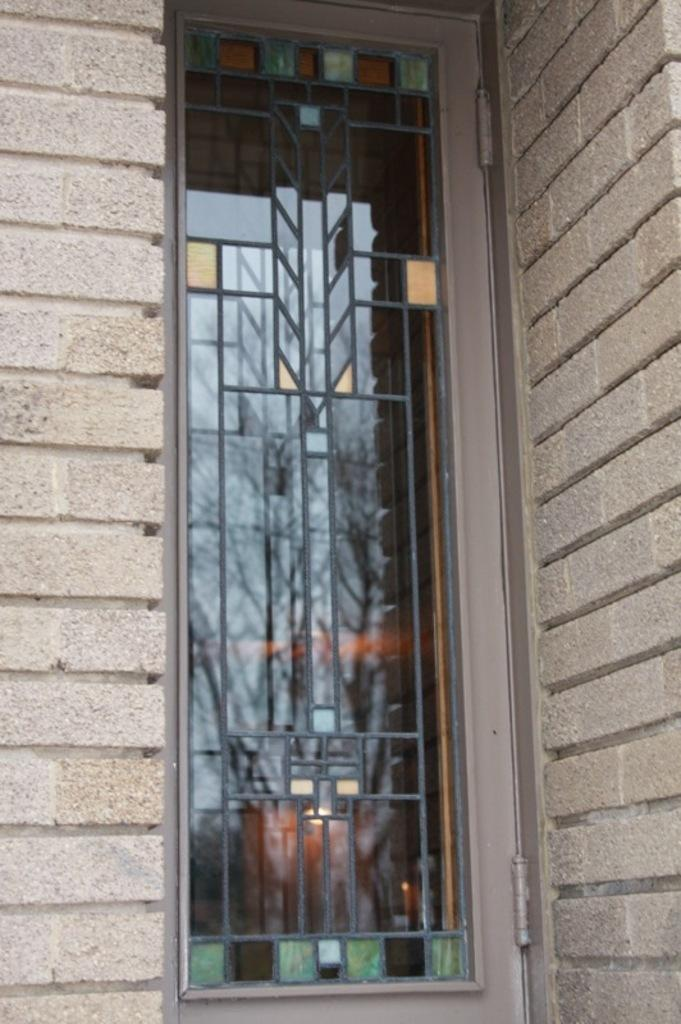What type of structure is present in the image? There is a building in the image. Can you describe any specific features of the building? The building has a window. How many giraffes can be seen walking in front of the building in the image? There are no giraffes present in the image, and therefore no such activity can be observed. 